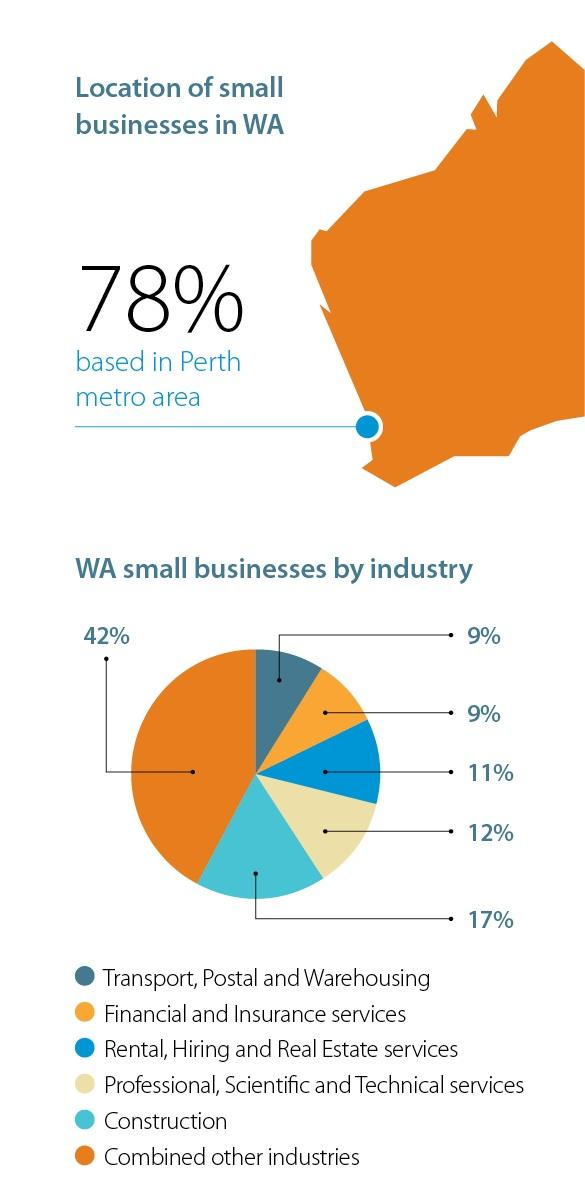Specify some key components in this picture. The transport, postal, and warehousing industry has a similar volume to that of the financial and insurance services industry. The professional, scientific, and technical service industry is less than construction by 5%. According to the provided data, the total percentage of construction and combined other industries is 59%. 